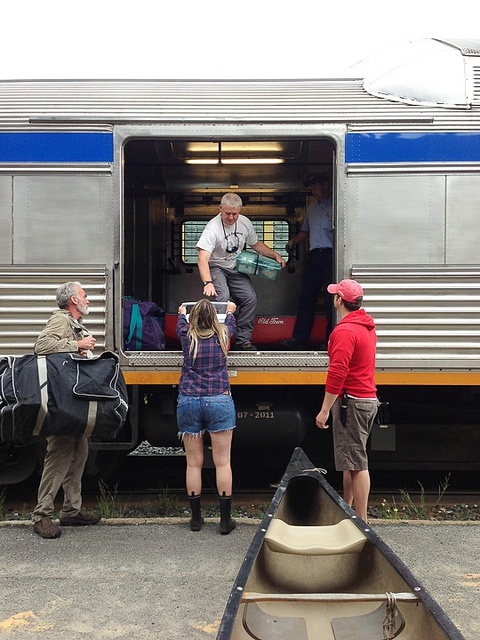Describe the objects in this image and their specific colors. I can see train in white, black, lightgray, darkgray, and gray tones, boat in white, gray, black, and darkgray tones, suitcase in white, black, gray, and darkgray tones, people in white, black, gray, and navy tones, and people in white, black, maroon, red, and brown tones in this image. 